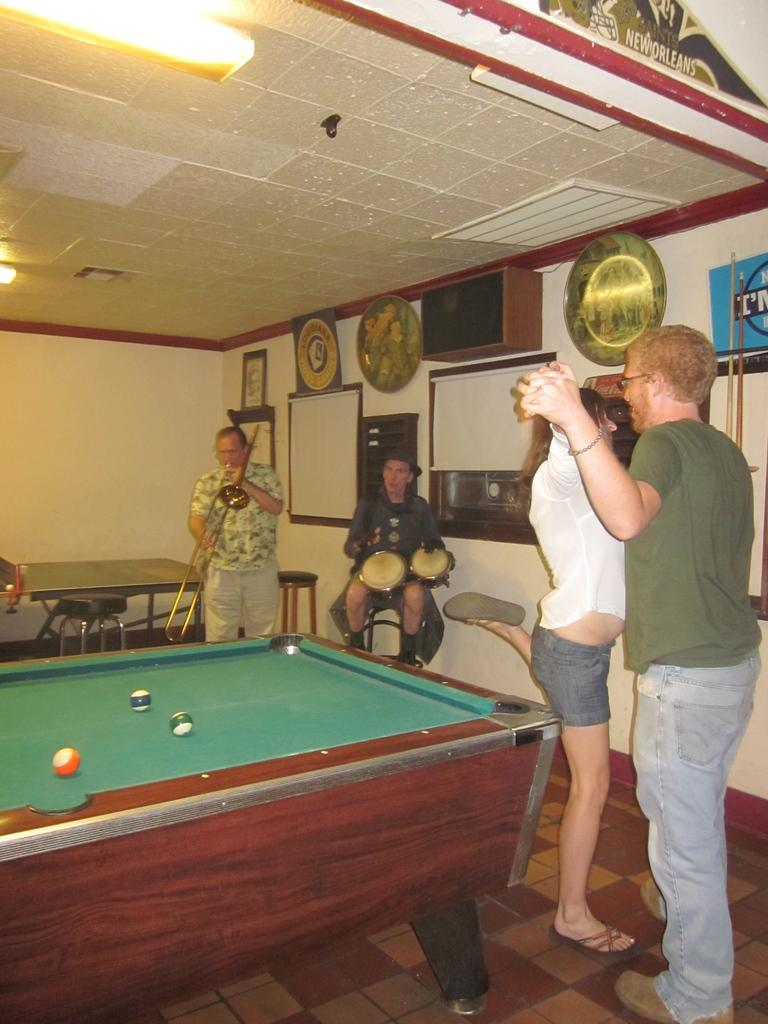What are the two persons in the image doing together? The two persons are holding hands and dancing. Who is providing the music for the dancing? There are two persons playing music in the image. What can be seen in the left corner of the image? There is a snooker table in the left corner of the image. What type of weather can be seen in the image? There is no weather depicted in the image, as it is an indoor scene. What is the value of the snooker table in the image? The value of the snooker table cannot be determined from the image alone, as it does not provide information about the table's condition, age, or brand. 